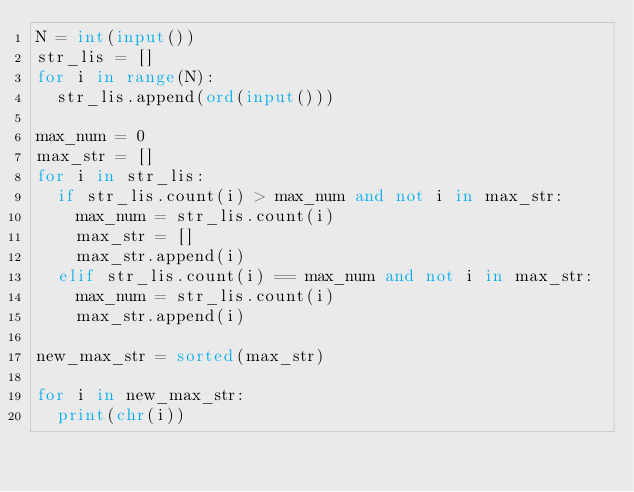<code> <loc_0><loc_0><loc_500><loc_500><_Python_>N = int(input())
str_lis = []
for i in range(N):
  str_lis.append(ord(input()))

max_num = 0
max_str = []
for i in str_lis:
  if str_lis.count(i) > max_num and not i in max_str:
    max_num = str_lis.count(i)
    max_str = []
    max_str.append(i)
  elif str_lis.count(i) == max_num and not i in max_str:
    max_num = str_lis.count(i)
    max_str.append(i)
    
new_max_str = sorted(max_str)

for i in new_max_str:
  print(chr(i))</code> 